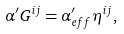<formula> <loc_0><loc_0><loc_500><loc_500>\alpha ^ { \prime } G ^ { i j } = \alpha _ { e f f } ^ { \prime } \eta ^ { i j } ,</formula> 